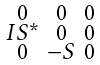Convert formula to latex. <formula><loc_0><loc_0><loc_500><loc_500>\begin{smallmatrix} 0 & 0 & 0 \\ I S ^ { * } & 0 & 0 \\ 0 & - S & 0 \end{smallmatrix}</formula> 